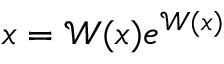Convert formula to latex. <formula><loc_0><loc_0><loc_500><loc_500>x = \mathcal { W } ( x ) e ^ { \mathcal { W } ( x ) }</formula> 